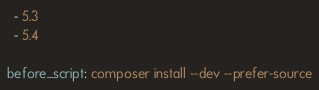<code> <loc_0><loc_0><loc_500><loc_500><_YAML_>  - 5.3
  - 5.4

before_script: composer install --dev --prefer-source
</code> 